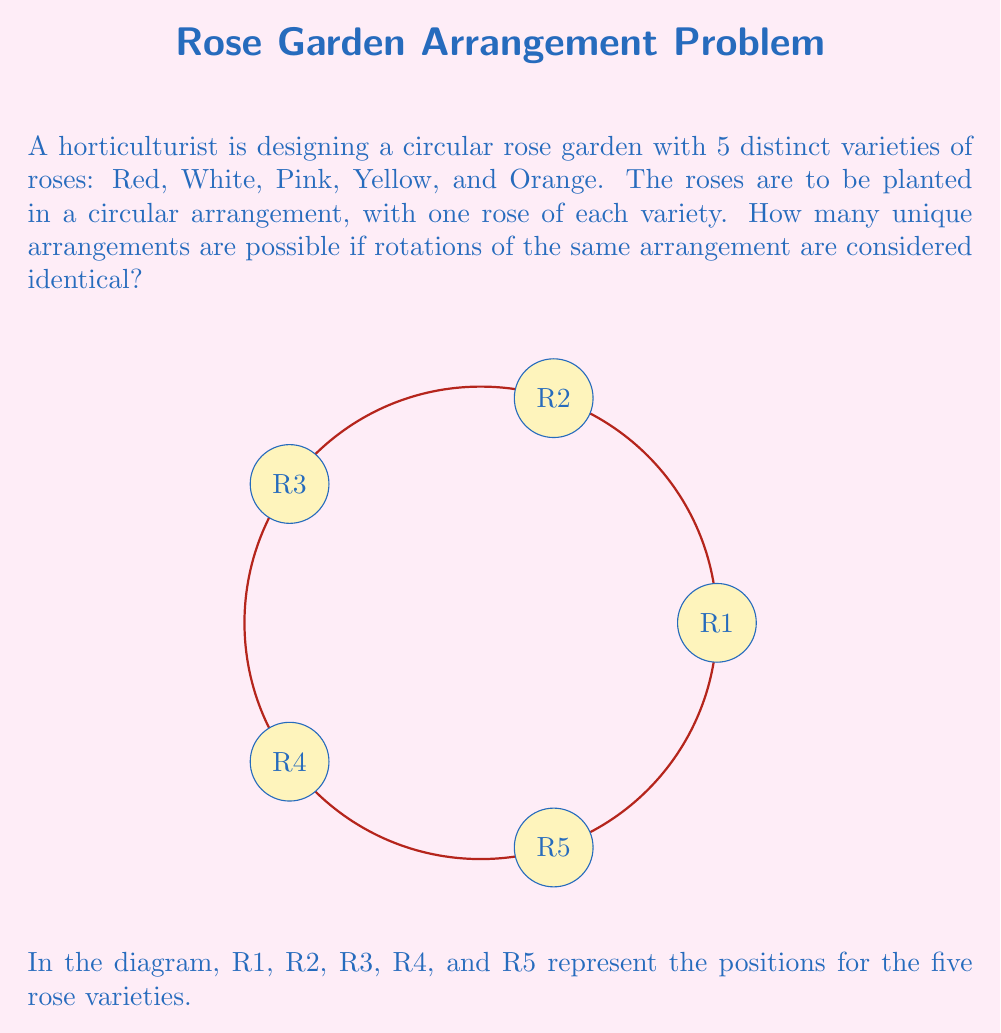Can you answer this question? Let's approach this step-by-step:

1) First, we need to understand that this problem involves the cyclic group $C_5$, which is a subgroup of the symmetric group $S_5$.

2) The total number of permutations of 5 elements is 5! = 120. This would be the answer if rotations were considered distinct.

3) However, since rotations are considered identical, we need to account for this. Each unique arrangement has 5 rotations that are considered the same (including the original arrangement).

4) Mathematically, we are looking for the number of cosets of $C_5$ in $S_5$. This is given by the index of $C_5$ in $S_5$, which we can calculate using Lagrange's theorem:

   $$[S_5 : C_5] = \frac{|S_5|}{|C_5|} = \frac{5!}{5} = \frac{120}{5} = 24$$

5) Therefore, there are 24 unique arrangements.

This result can also be thought of as dividing the total number of permutations by the number of rotations that are considered identical for each arrangement:

$$\frac{\text{Total permutations}}{\text{Rotations per arrangement}} = \frac{5!}{5} = 24$$
Answer: 24 unique arrangements 